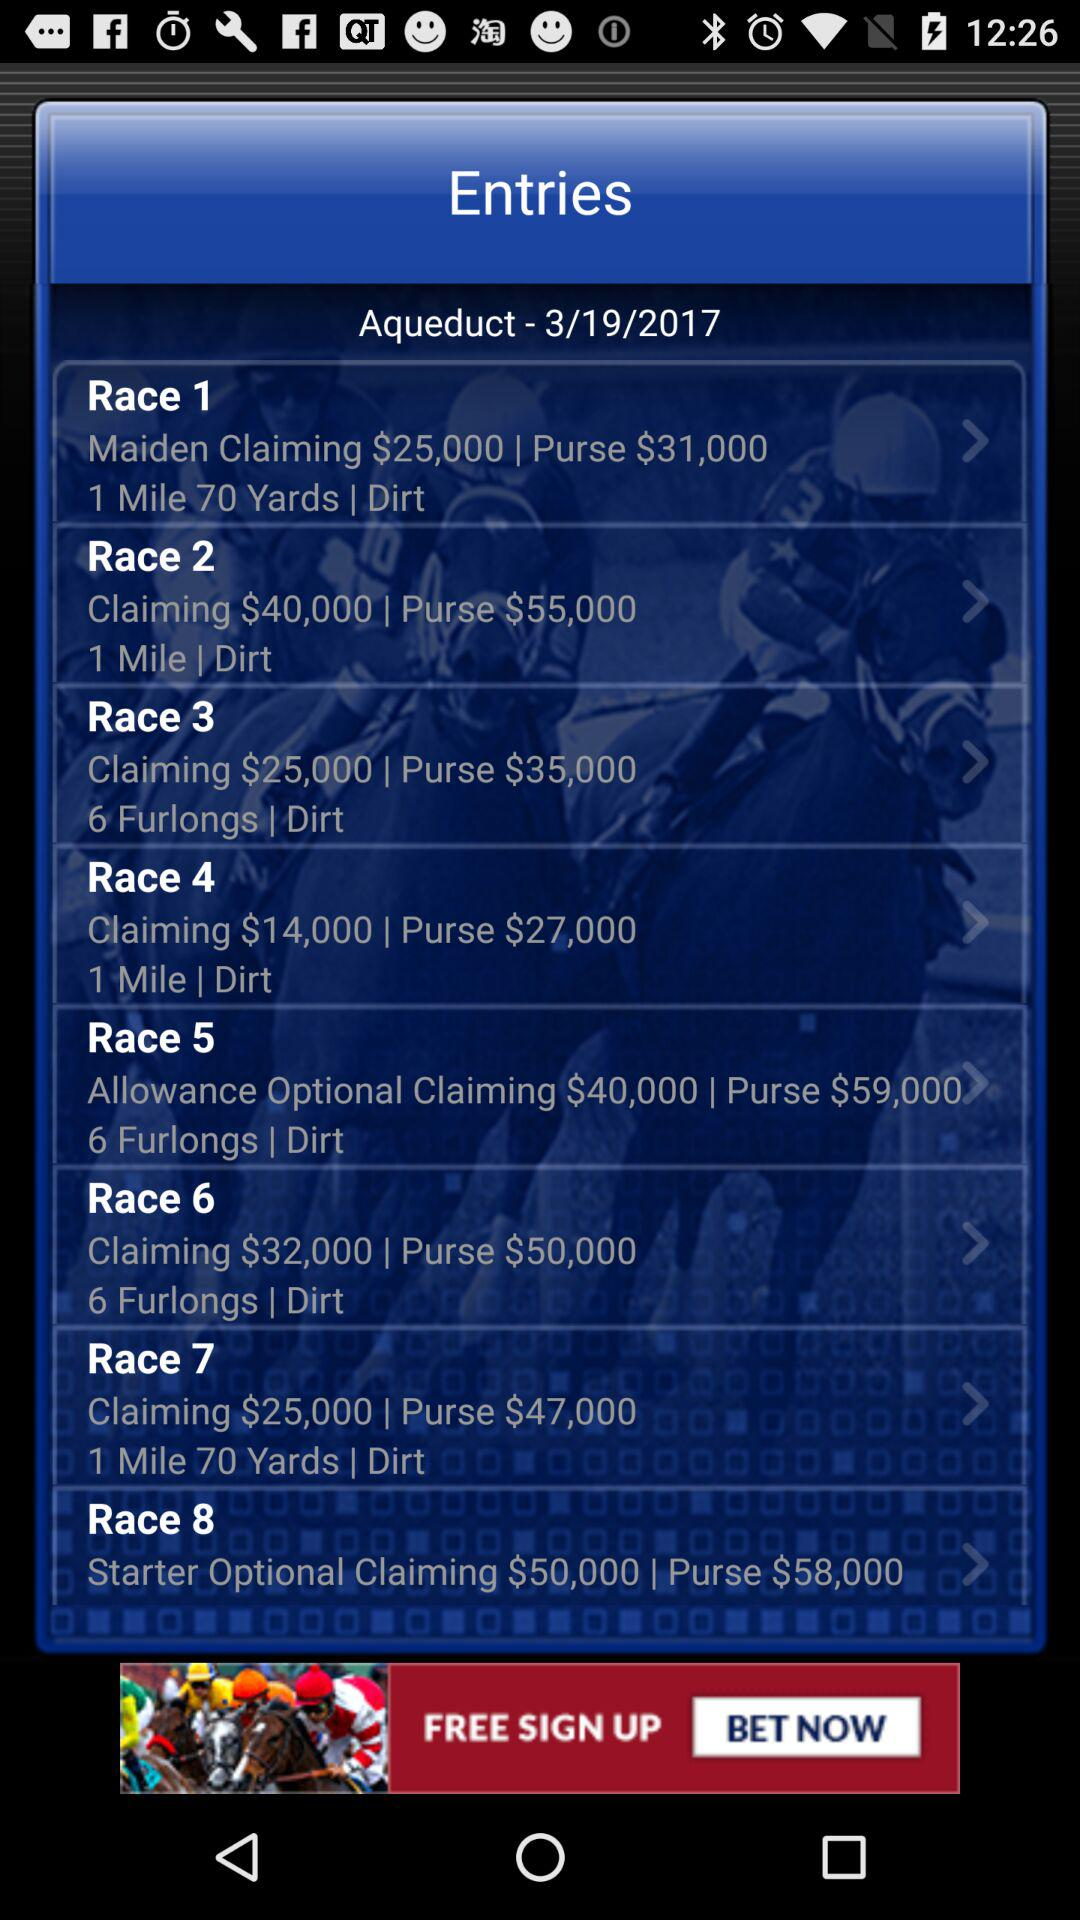What is the claim amount for "Race 4"? The claim amount is $14,000. 